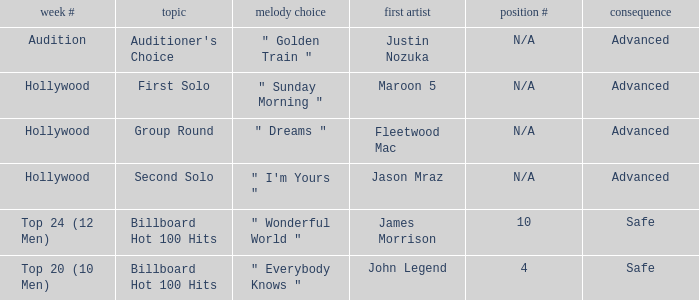What are all the results of songs is " golden train " Advanced. 